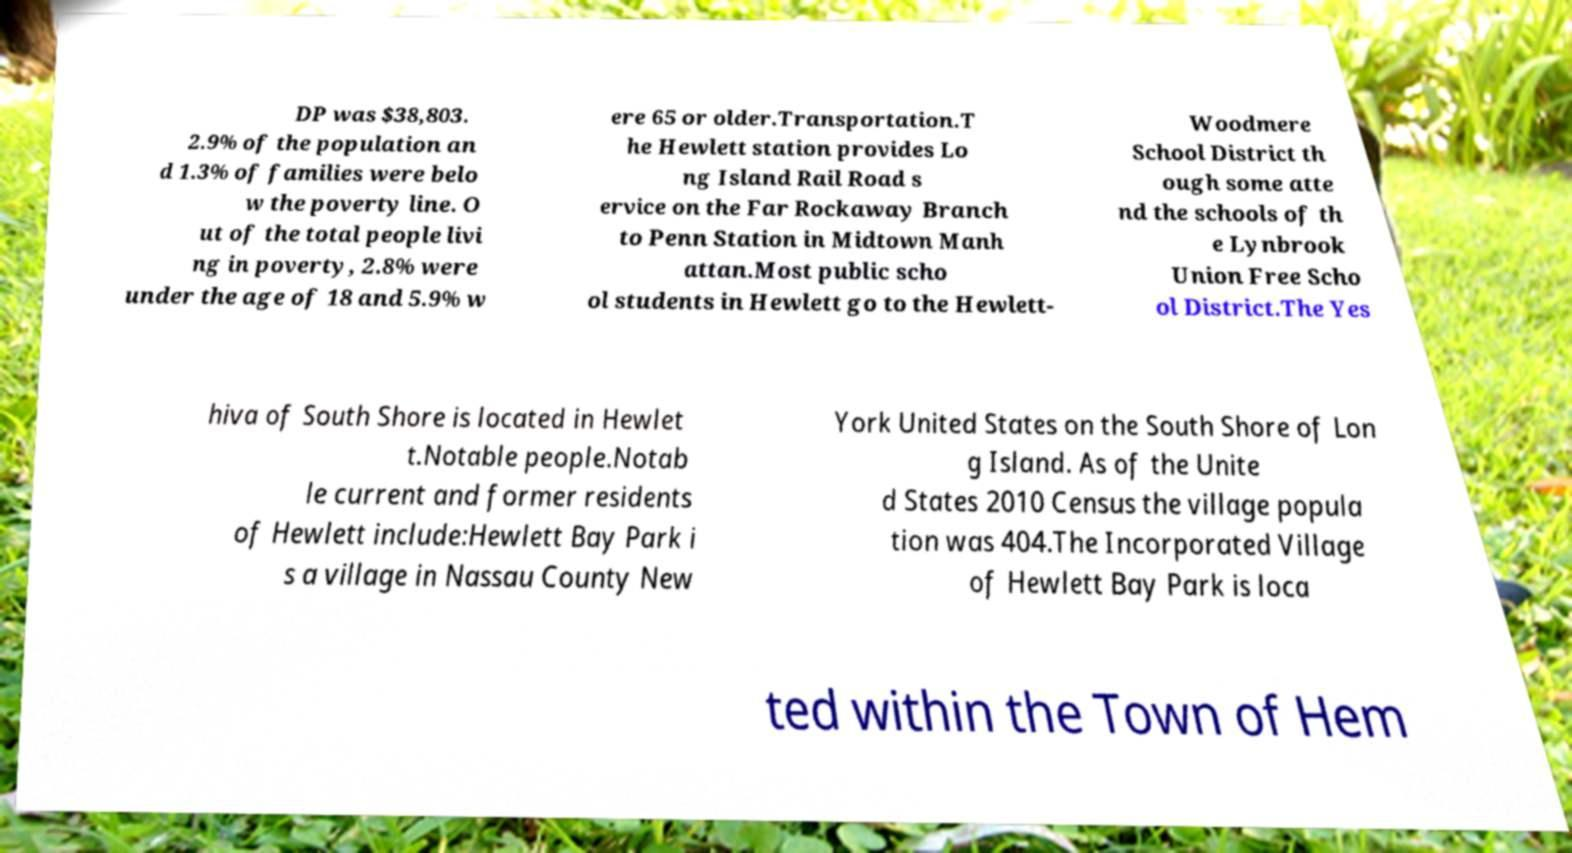Please read and relay the text visible in this image. What does it say? DP was $38,803. 2.9% of the population an d 1.3% of families were belo w the poverty line. O ut of the total people livi ng in poverty, 2.8% were under the age of 18 and 5.9% w ere 65 or older.Transportation.T he Hewlett station provides Lo ng Island Rail Road s ervice on the Far Rockaway Branch to Penn Station in Midtown Manh attan.Most public scho ol students in Hewlett go to the Hewlett- Woodmere School District th ough some atte nd the schools of th e Lynbrook Union Free Scho ol District.The Yes hiva of South Shore is located in Hewlet t.Notable people.Notab le current and former residents of Hewlett include:Hewlett Bay Park i s a village in Nassau County New York United States on the South Shore of Lon g Island. As of the Unite d States 2010 Census the village popula tion was 404.The Incorporated Village of Hewlett Bay Park is loca ted within the Town of Hem 